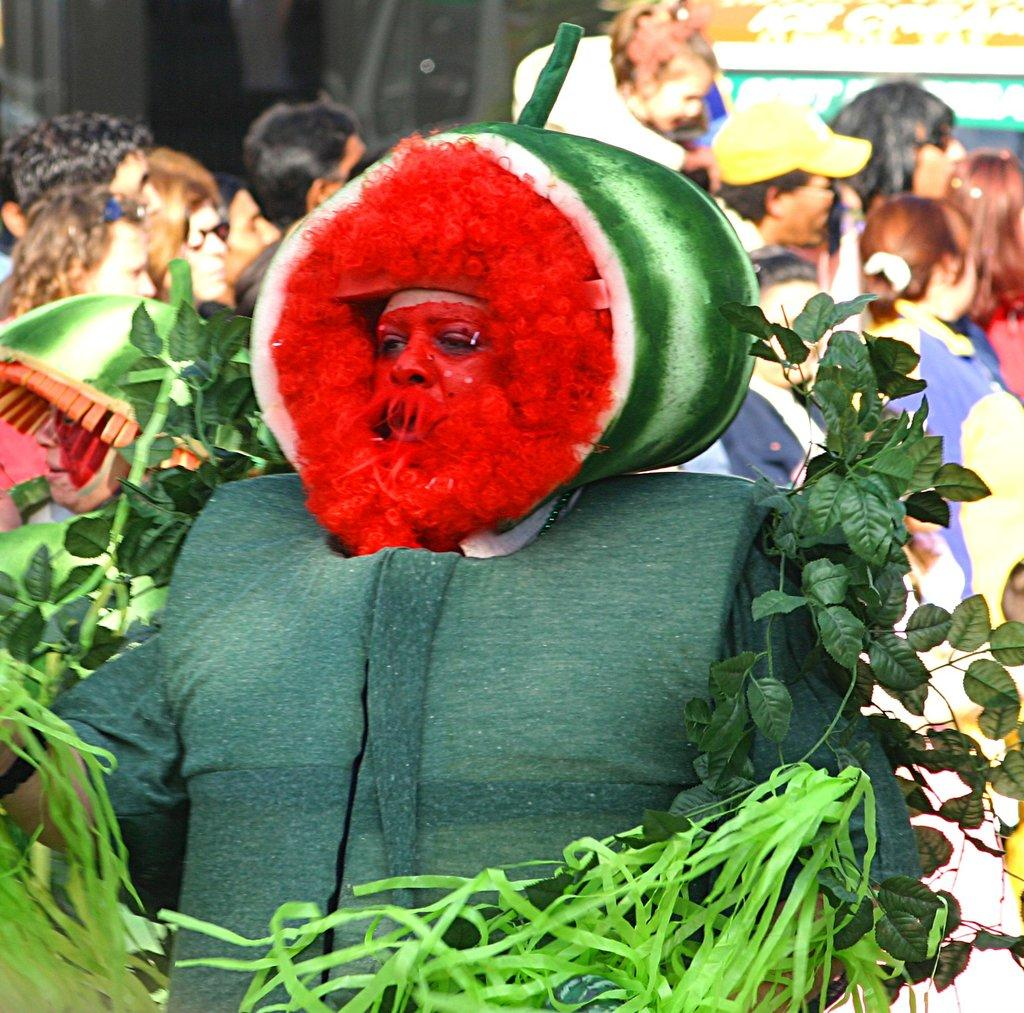What is the person in the image wearing? The person in the image is wearing costumes. What can be seen around the person? There are leaves around the person. How many people are visible behind the person? There are many people standing behind the person. Can you describe the background of the image? The background of the image is blurred. What type of toothbrush is visible in the image? There is no toothbrush present in the image. What color is the grass in the image? There is no grass present in the image. 